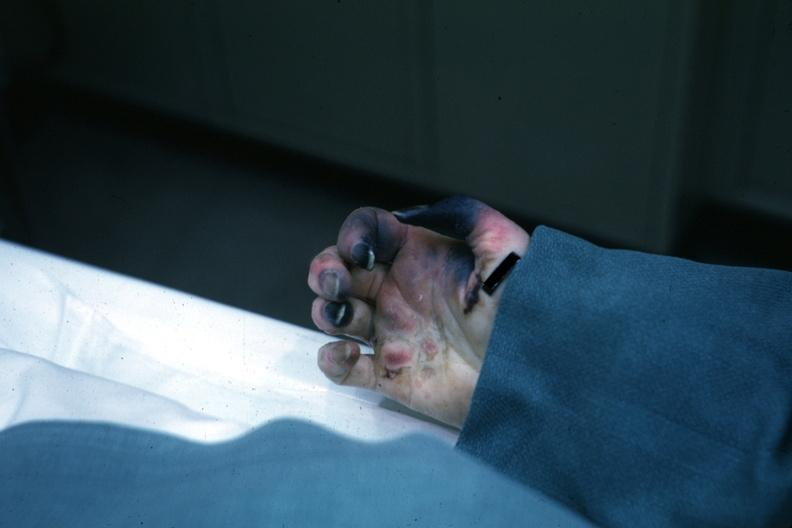does exact cause know shock vs emboli?
Answer the question using a single word or phrase. Yes 